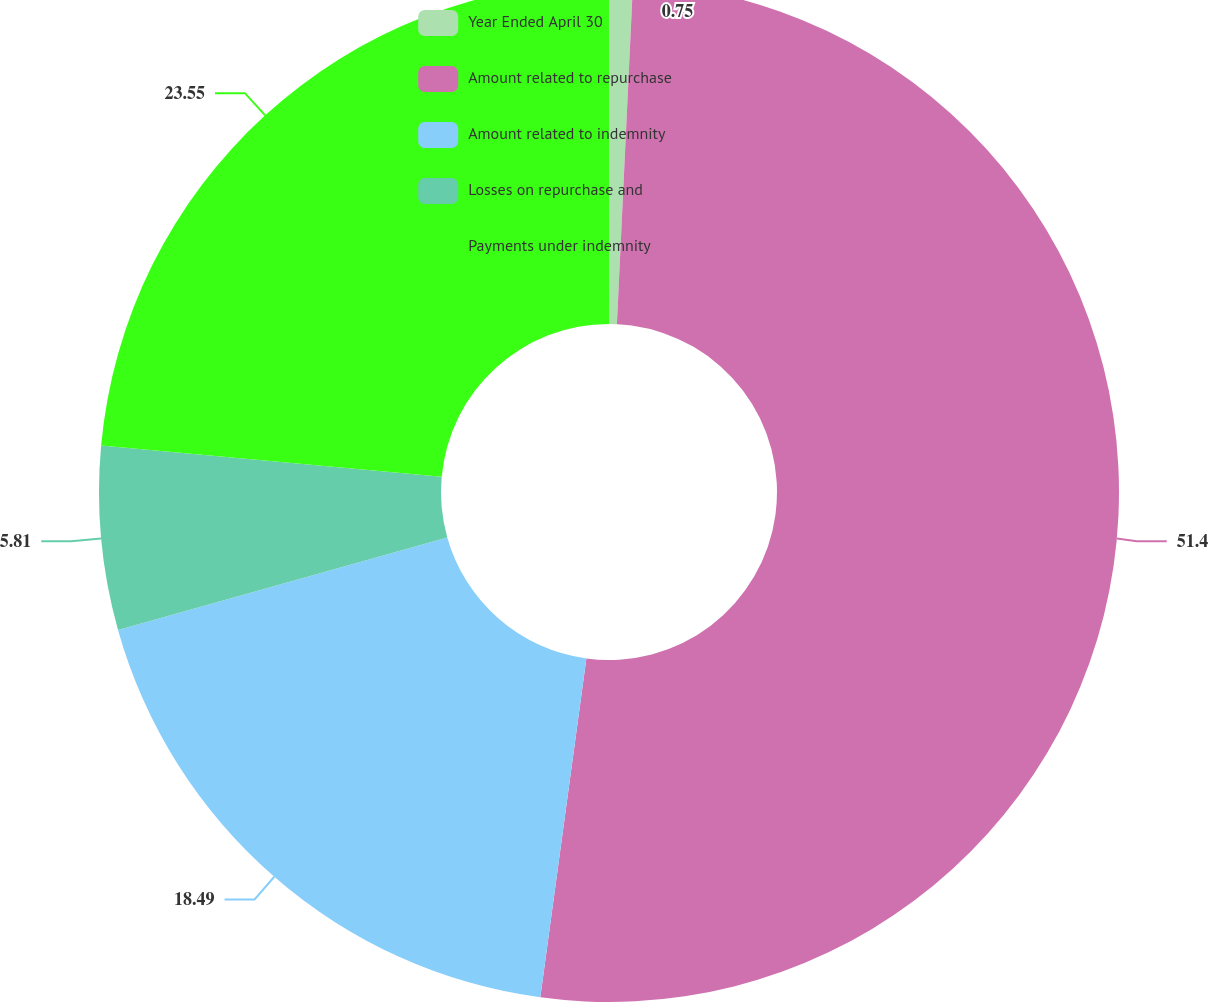<chart> <loc_0><loc_0><loc_500><loc_500><pie_chart><fcel>Year Ended April 30<fcel>Amount related to repurchase<fcel>Amount related to indemnity<fcel>Losses on repurchase and<fcel>Payments under indemnity<nl><fcel>0.75%<fcel>51.4%<fcel>18.49%<fcel>5.81%<fcel>23.55%<nl></chart> 